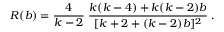<formula> <loc_0><loc_0><loc_500><loc_500>R ( b ) = \frac { 4 } { k - 2 } \, \frac { k ( k - 4 ) + k ( k - 2 ) b } { [ k + 2 + ( k - 2 ) b ] ^ { 2 } } \, .</formula> 